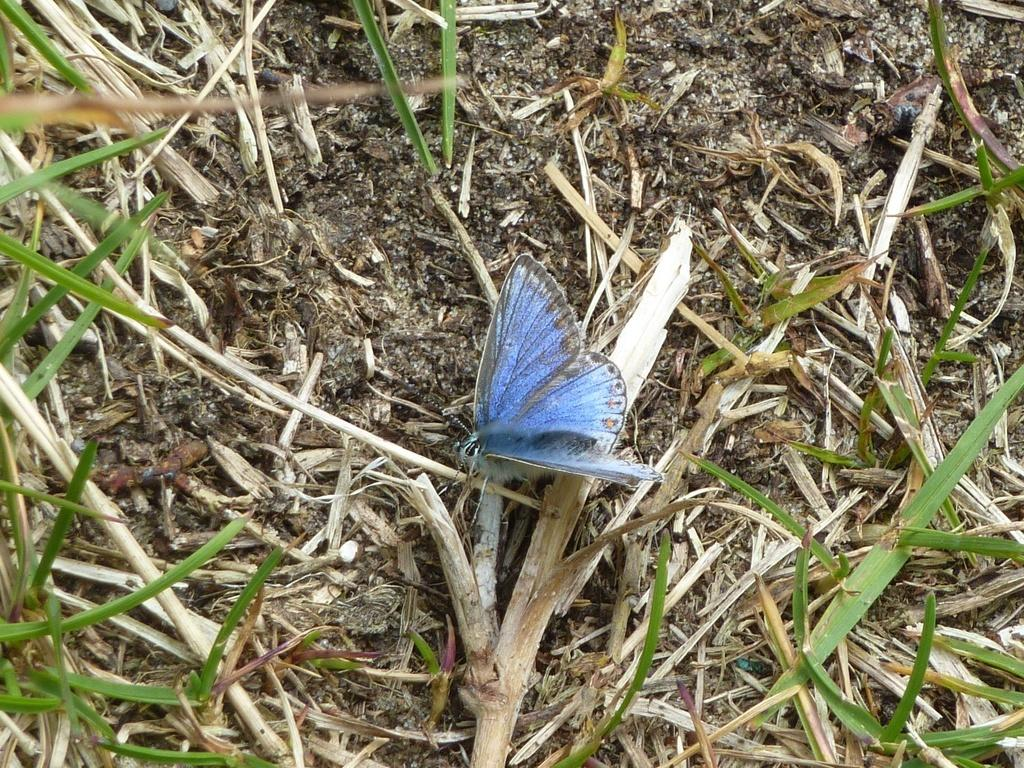What type of creature is present in the image? There is a butterfly in the image. What color is the butterfly? The butterfly is blue in color. What type of vegetation can be seen on the ground in the image? There is grass visible on the ground in the image. What type of legal advice can be obtained from the butterfly in the image? There is no lawyer or legal advice present in the image, as it features a blue butterfly and grass. 